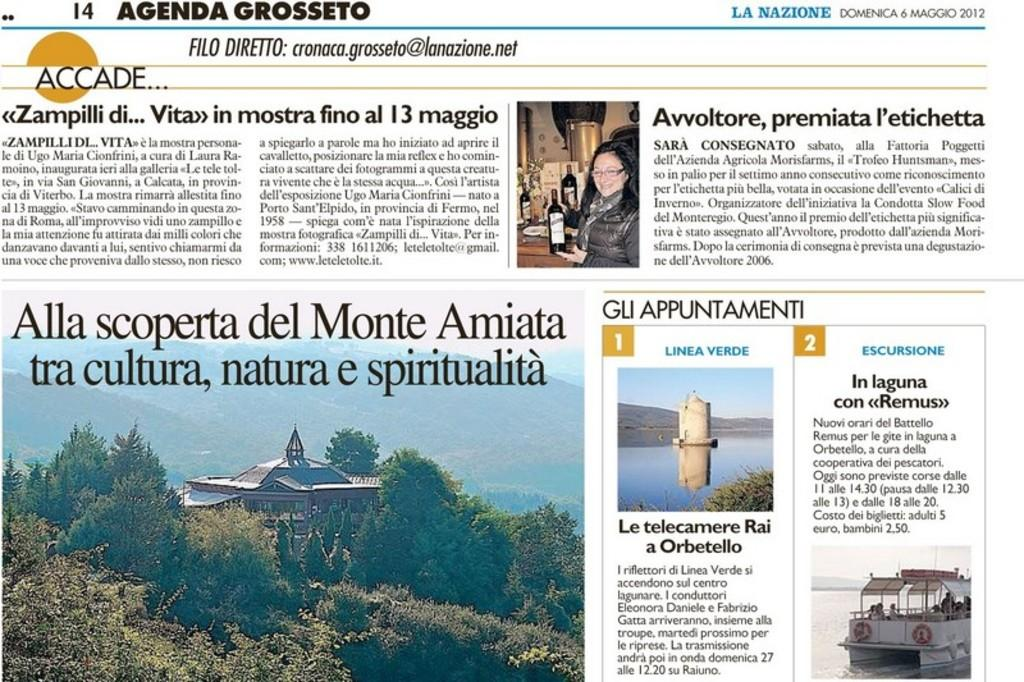<image>
Create a compact narrative representing the image presented. A newspaper page that includes the agenda grosseto. 